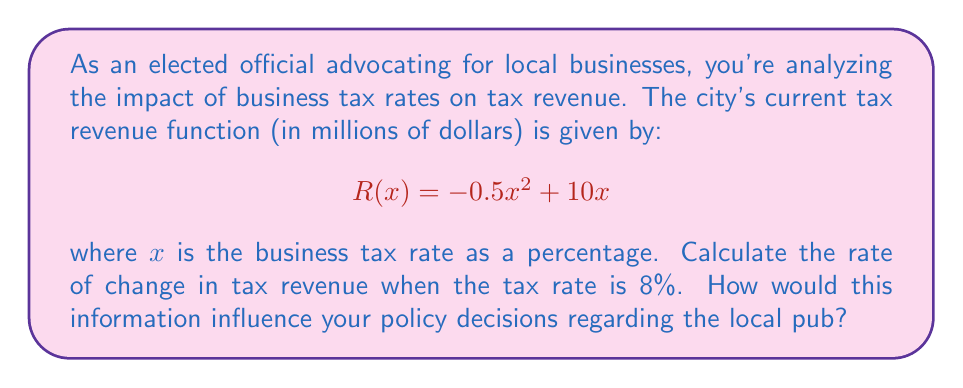Show me your answer to this math problem. To solve this problem, we need to find the derivative of the tax revenue function and evaluate it at $x = 8$. This will give us the rate of change in tax revenue at that point.

1. First, let's find the derivative of $R(x)$:
   $$R'(x) = \frac{d}{dx}(-0.5x^2 + 10x)$$
   $$R'(x) = -x + 10$$

2. Now, we evaluate $R'(x)$ at $x = 8$:
   $$R'(8) = -8 + 10 = 2$$

3. Interpretation:
   The rate of change in tax revenue when the tax rate is 8% is 2 million dollars per percentage point. This means that for a small increase in the tax rate from 8%, we can expect the tax revenue to increase by approximately $2 million for each percentage point increase.

4. Policy implications:
   As an advocate for local businesses, including the pub, you might consider that:
   a) The positive rate of change suggests that a small increase in the tax rate could generate more revenue for the city.
   b) However, increasing taxes might put a burden on local businesses, potentially affecting their profitability and growth.
   c) You may want to balance the potential for increased revenue with the need to maintain a business-friendly environment.
   d) For the local pub specifically, you might consider how sensitive it is to tax changes and whether alternative support measures (e.g., grants, reduced regulations) might be more beneficial than adjusting tax rates.
Answer: The rate of change in tax revenue when the business tax rate is 8% is $2$ million dollars per percentage point. 